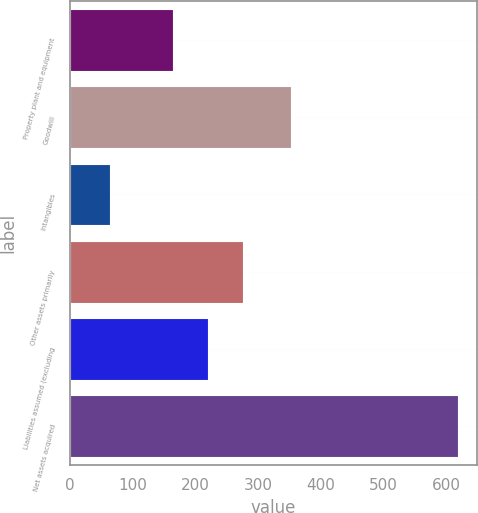<chart> <loc_0><loc_0><loc_500><loc_500><bar_chart><fcel>Property plant and equipment<fcel>Goodwill<fcel>Intangibles<fcel>Other assets primarily<fcel>Liabilities assumed (excluding<fcel>Net assets acquired<nl><fcel>164.6<fcel>353.2<fcel>63.9<fcel>275.4<fcel>220<fcel>617.9<nl></chart> 